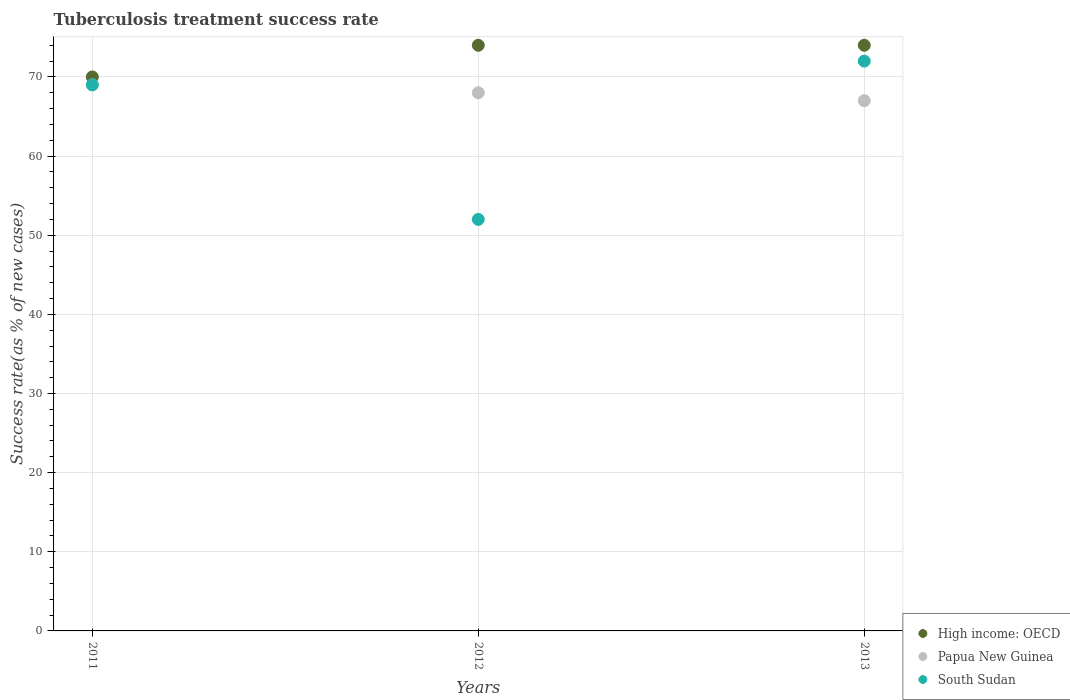How many different coloured dotlines are there?
Give a very brief answer. 3. What is the tuberculosis treatment success rate in High income: OECD in 2012?
Offer a very short reply. 74. Across all years, what is the minimum tuberculosis treatment success rate in South Sudan?
Your answer should be compact. 52. In which year was the tuberculosis treatment success rate in South Sudan maximum?
Provide a short and direct response. 2013. What is the total tuberculosis treatment success rate in South Sudan in the graph?
Ensure brevity in your answer.  193. What is the difference between the tuberculosis treatment success rate in High income: OECD in 2011 and that in 2013?
Offer a terse response. -4. What is the difference between the tuberculosis treatment success rate in High income: OECD in 2011 and the tuberculosis treatment success rate in South Sudan in 2012?
Provide a succinct answer. 18. What is the average tuberculosis treatment success rate in South Sudan per year?
Make the answer very short. 64.33. In the year 2011, what is the difference between the tuberculosis treatment success rate in High income: OECD and tuberculosis treatment success rate in South Sudan?
Your answer should be compact. 1. What is the ratio of the tuberculosis treatment success rate in South Sudan in 2012 to that in 2013?
Ensure brevity in your answer.  0.72. Is the tuberculosis treatment success rate in Papua New Guinea in 2011 less than that in 2013?
Offer a very short reply. No. Is the difference between the tuberculosis treatment success rate in High income: OECD in 2011 and 2013 greater than the difference between the tuberculosis treatment success rate in South Sudan in 2011 and 2013?
Ensure brevity in your answer.  No. What is the difference between the highest and the lowest tuberculosis treatment success rate in Papua New Guinea?
Offer a very short reply. 2. Is it the case that in every year, the sum of the tuberculosis treatment success rate in Papua New Guinea and tuberculosis treatment success rate in High income: OECD  is greater than the tuberculosis treatment success rate in South Sudan?
Offer a terse response. Yes. Is the tuberculosis treatment success rate in High income: OECD strictly greater than the tuberculosis treatment success rate in South Sudan over the years?
Your answer should be compact. Yes. Is the tuberculosis treatment success rate in High income: OECD strictly less than the tuberculosis treatment success rate in South Sudan over the years?
Provide a short and direct response. No. How many dotlines are there?
Provide a short and direct response. 3. How many years are there in the graph?
Your response must be concise. 3. Are the values on the major ticks of Y-axis written in scientific E-notation?
Provide a short and direct response. No. Does the graph contain grids?
Give a very brief answer. Yes. How many legend labels are there?
Keep it short and to the point. 3. How are the legend labels stacked?
Your response must be concise. Vertical. What is the title of the graph?
Give a very brief answer. Tuberculosis treatment success rate. What is the label or title of the Y-axis?
Give a very brief answer. Success rate(as % of new cases). What is the Success rate(as % of new cases) of High income: OECD in 2011?
Your answer should be very brief. 70. What is the Success rate(as % of new cases) in South Sudan in 2011?
Provide a succinct answer. 69. What is the Success rate(as % of new cases) of High income: OECD in 2013?
Offer a terse response. 74. Across all years, what is the maximum Success rate(as % of new cases) of High income: OECD?
Make the answer very short. 74. Across all years, what is the maximum Success rate(as % of new cases) of Papua New Guinea?
Your answer should be compact. 69. Across all years, what is the maximum Success rate(as % of new cases) of South Sudan?
Ensure brevity in your answer.  72. Across all years, what is the minimum Success rate(as % of new cases) in Papua New Guinea?
Give a very brief answer. 67. Across all years, what is the minimum Success rate(as % of new cases) in South Sudan?
Keep it short and to the point. 52. What is the total Success rate(as % of new cases) of High income: OECD in the graph?
Your response must be concise. 218. What is the total Success rate(as % of new cases) in Papua New Guinea in the graph?
Keep it short and to the point. 204. What is the total Success rate(as % of new cases) of South Sudan in the graph?
Your response must be concise. 193. What is the difference between the Success rate(as % of new cases) in High income: OECD in 2011 and that in 2012?
Make the answer very short. -4. What is the difference between the Success rate(as % of new cases) in Papua New Guinea in 2011 and that in 2013?
Your response must be concise. 2. What is the difference between the Success rate(as % of new cases) in South Sudan in 2011 and that in 2013?
Offer a very short reply. -3. What is the difference between the Success rate(as % of new cases) of High income: OECD in 2012 and that in 2013?
Provide a short and direct response. 0. What is the difference between the Success rate(as % of new cases) in Papua New Guinea in 2012 and that in 2013?
Your response must be concise. 1. What is the difference between the Success rate(as % of new cases) in South Sudan in 2012 and that in 2013?
Offer a very short reply. -20. What is the difference between the Success rate(as % of new cases) in High income: OECD in 2011 and the Success rate(as % of new cases) in Papua New Guinea in 2012?
Provide a succinct answer. 2. What is the difference between the Success rate(as % of new cases) in High income: OECD in 2011 and the Success rate(as % of new cases) in South Sudan in 2012?
Provide a succinct answer. 18. What is the difference between the Success rate(as % of new cases) in High income: OECD in 2011 and the Success rate(as % of new cases) in South Sudan in 2013?
Make the answer very short. -2. What is the difference between the Success rate(as % of new cases) of High income: OECD in 2012 and the Success rate(as % of new cases) of Papua New Guinea in 2013?
Provide a short and direct response. 7. What is the difference between the Success rate(as % of new cases) in Papua New Guinea in 2012 and the Success rate(as % of new cases) in South Sudan in 2013?
Ensure brevity in your answer.  -4. What is the average Success rate(as % of new cases) of High income: OECD per year?
Ensure brevity in your answer.  72.67. What is the average Success rate(as % of new cases) of Papua New Guinea per year?
Your response must be concise. 68. What is the average Success rate(as % of new cases) in South Sudan per year?
Give a very brief answer. 64.33. In the year 2011, what is the difference between the Success rate(as % of new cases) of High income: OECD and Success rate(as % of new cases) of Papua New Guinea?
Your answer should be compact. 1. In the year 2011, what is the difference between the Success rate(as % of new cases) in Papua New Guinea and Success rate(as % of new cases) in South Sudan?
Provide a succinct answer. 0. In the year 2012, what is the difference between the Success rate(as % of new cases) in High income: OECD and Success rate(as % of new cases) in Papua New Guinea?
Keep it short and to the point. 6. In the year 2012, what is the difference between the Success rate(as % of new cases) of High income: OECD and Success rate(as % of new cases) of South Sudan?
Your response must be concise. 22. In the year 2012, what is the difference between the Success rate(as % of new cases) of Papua New Guinea and Success rate(as % of new cases) of South Sudan?
Provide a short and direct response. 16. In the year 2013, what is the difference between the Success rate(as % of new cases) in High income: OECD and Success rate(as % of new cases) in South Sudan?
Your answer should be compact. 2. What is the ratio of the Success rate(as % of new cases) in High income: OECD in 2011 to that in 2012?
Keep it short and to the point. 0.95. What is the ratio of the Success rate(as % of new cases) of Papua New Guinea in 2011 to that in 2012?
Offer a very short reply. 1.01. What is the ratio of the Success rate(as % of new cases) of South Sudan in 2011 to that in 2012?
Give a very brief answer. 1.33. What is the ratio of the Success rate(as % of new cases) in High income: OECD in 2011 to that in 2013?
Ensure brevity in your answer.  0.95. What is the ratio of the Success rate(as % of new cases) of Papua New Guinea in 2011 to that in 2013?
Ensure brevity in your answer.  1.03. What is the ratio of the Success rate(as % of new cases) of South Sudan in 2011 to that in 2013?
Make the answer very short. 0.96. What is the ratio of the Success rate(as % of new cases) of Papua New Guinea in 2012 to that in 2013?
Make the answer very short. 1.01. What is the ratio of the Success rate(as % of new cases) of South Sudan in 2012 to that in 2013?
Your response must be concise. 0.72. What is the difference between the highest and the second highest Success rate(as % of new cases) of High income: OECD?
Your answer should be very brief. 0. What is the difference between the highest and the second highest Success rate(as % of new cases) of Papua New Guinea?
Ensure brevity in your answer.  1. What is the difference between the highest and the lowest Success rate(as % of new cases) in High income: OECD?
Give a very brief answer. 4. 